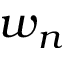Convert formula to latex. <formula><loc_0><loc_0><loc_500><loc_500>w _ { n }</formula> 